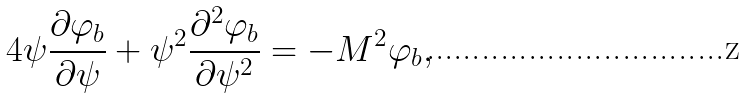Convert formula to latex. <formula><loc_0><loc_0><loc_500><loc_500>4 \psi \frac { \partial \varphi _ { b } } { \partial \psi } + \psi ^ { 2 } \frac { \partial ^ { 2 } \varphi _ { b } } { \partial \psi ^ { 2 } } = - M ^ { 2 } \varphi _ { b } ,</formula> 